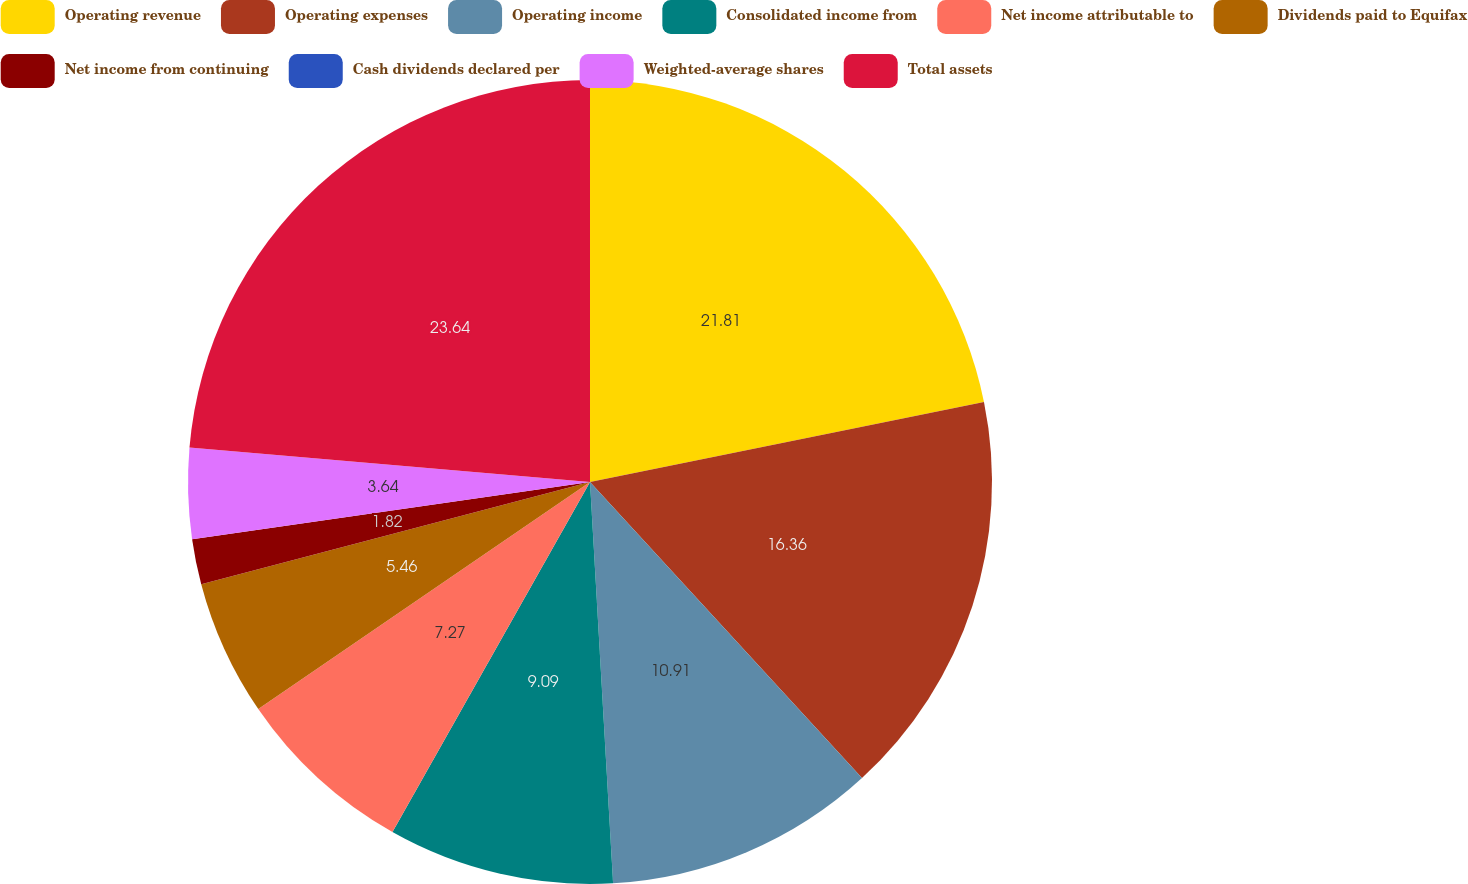Convert chart. <chart><loc_0><loc_0><loc_500><loc_500><pie_chart><fcel>Operating revenue<fcel>Operating expenses<fcel>Operating income<fcel>Consolidated income from<fcel>Net income attributable to<fcel>Dividends paid to Equifax<fcel>Net income from continuing<fcel>Cash dividends declared per<fcel>Weighted-average shares<fcel>Total assets<nl><fcel>21.81%<fcel>16.36%<fcel>10.91%<fcel>9.09%<fcel>7.27%<fcel>5.46%<fcel>1.82%<fcel>0.0%<fcel>3.64%<fcel>23.63%<nl></chart> 